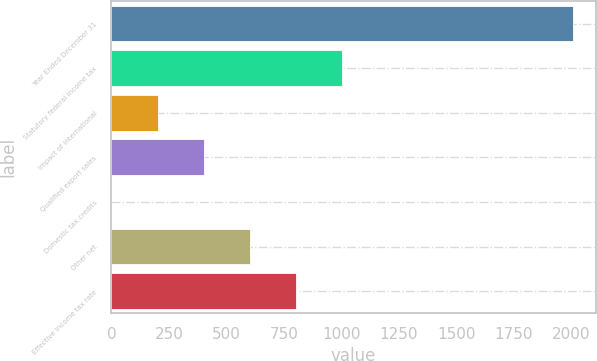<chart> <loc_0><loc_0><loc_500><loc_500><bar_chart><fcel>Year Ended December 31<fcel>Statutory federal income tax<fcel>Impact of international<fcel>Qualified export sales<fcel>Domestic tax credits<fcel>Other net<fcel>Effective income tax rate<nl><fcel>2005<fcel>1002.6<fcel>200.68<fcel>401.16<fcel>0.2<fcel>601.64<fcel>802.12<nl></chart> 